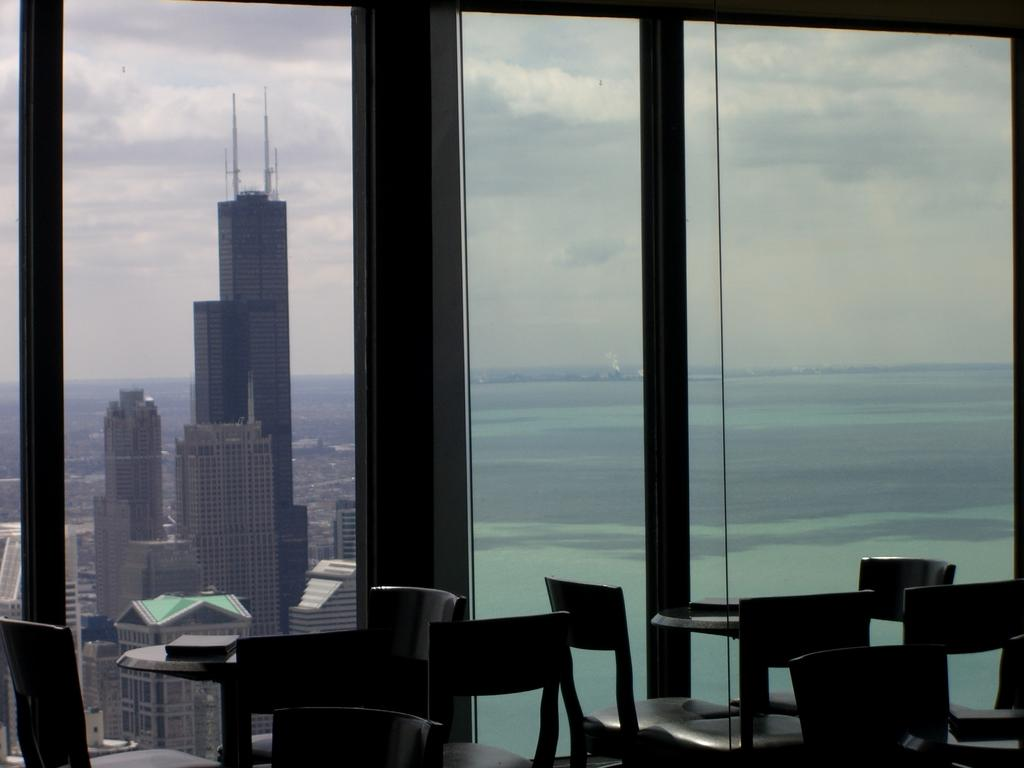What type of structure is present in the image? There is a glass window in the image. What can be seen through the glass window? Clouds and buildings are visible through the glass window. What type of furniture is located at the bottom of the image? There are chairs and tables at the bottom of the image. Who is the manager of the dolls in the image? There are no dolls or a manager present in the image. 